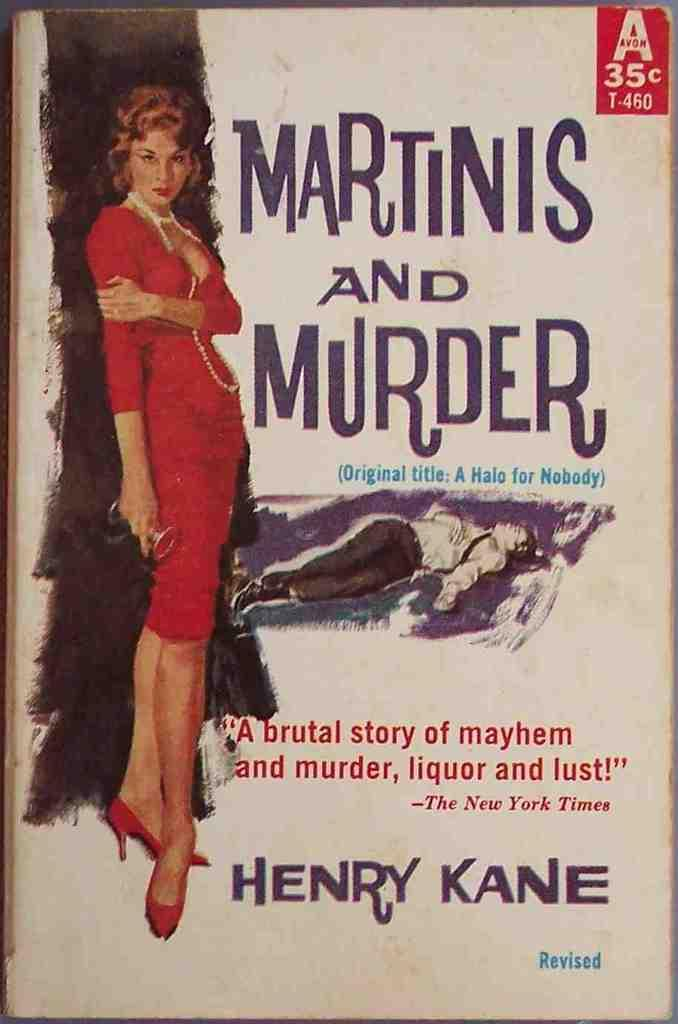Provide a one-sentence caption for the provided image. An old book that cost 35 cents titled Martinis and Murder. 